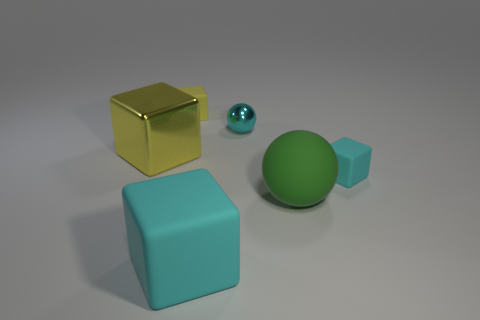Subtract all purple cubes. Subtract all gray spheres. How many cubes are left? 4 Add 3 small red matte things. How many objects exist? 9 Subtract all spheres. How many objects are left? 4 Add 2 tiny gray cubes. How many tiny gray cubes exist? 2 Subtract 0 blue cylinders. How many objects are left? 6 Subtract all large things. Subtract all small yellow matte cubes. How many objects are left? 2 Add 3 spheres. How many spheres are left? 5 